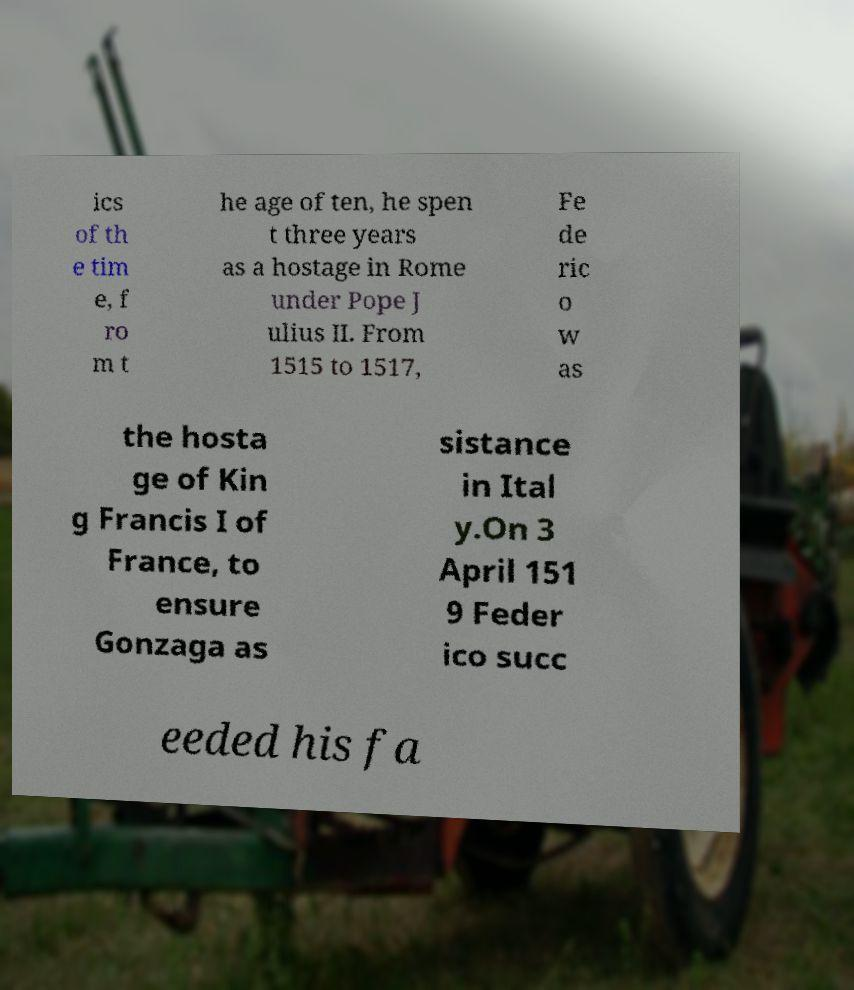Can you accurately transcribe the text from the provided image for me? ics of th e tim e, f ro m t he age of ten, he spen t three years as a hostage in Rome under Pope J ulius II. From 1515 to 1517, Fe de ric o w as the hosta ge of Kin g Francis I of France, to ensure Gonzaga as sistance in Ital y.On 3 April 151 9 Feder ico succ eeded his fa 